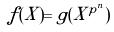<formula> <loc_0><loc_0><loc_500><loc_500>f ( X ) = g ( X ^ { p ^ { n } } )</formula> 